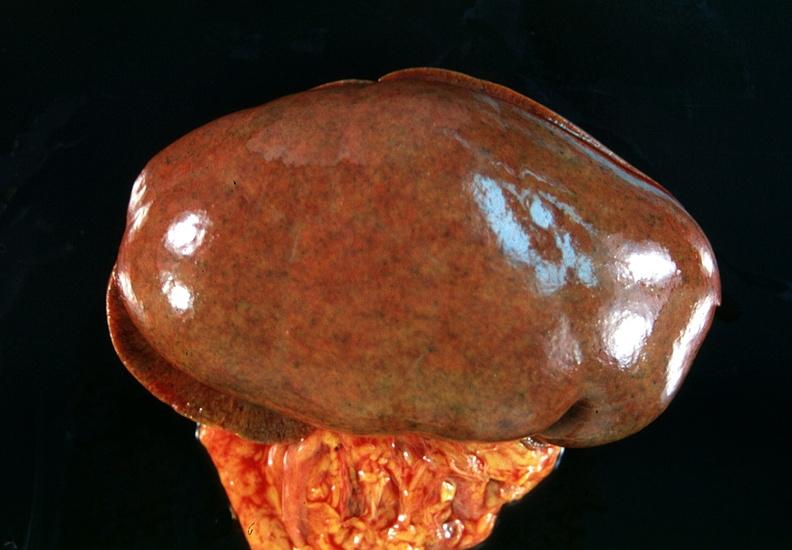does this image show kidney, congestion?
Answer the question using a single word or phrase. Yes 